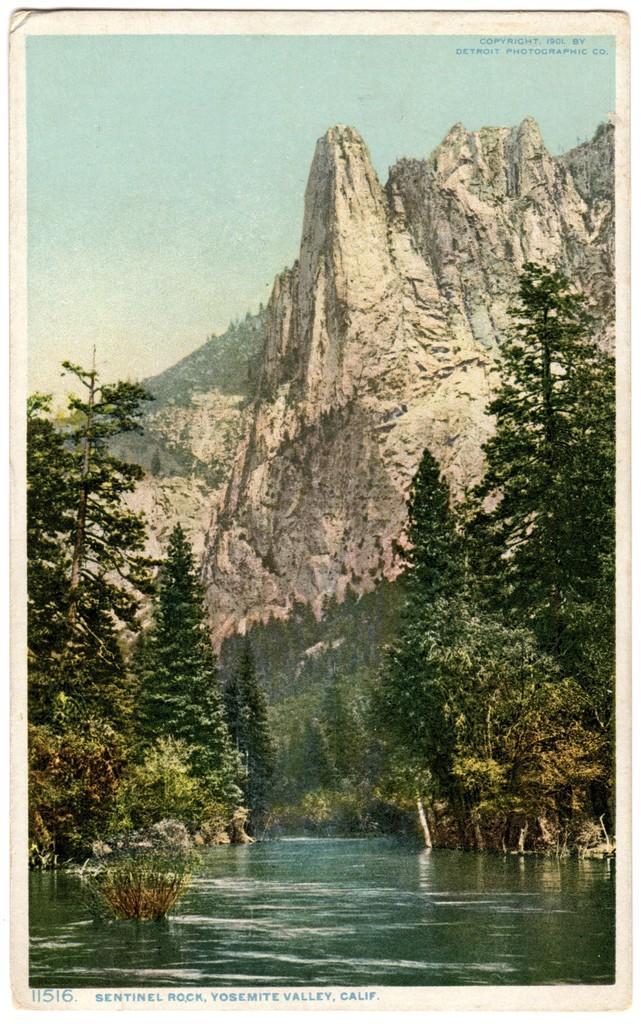Can you describe this image briefly? In this picture we can see trees, water, mountains, rocks and in the background we can see the sky. 